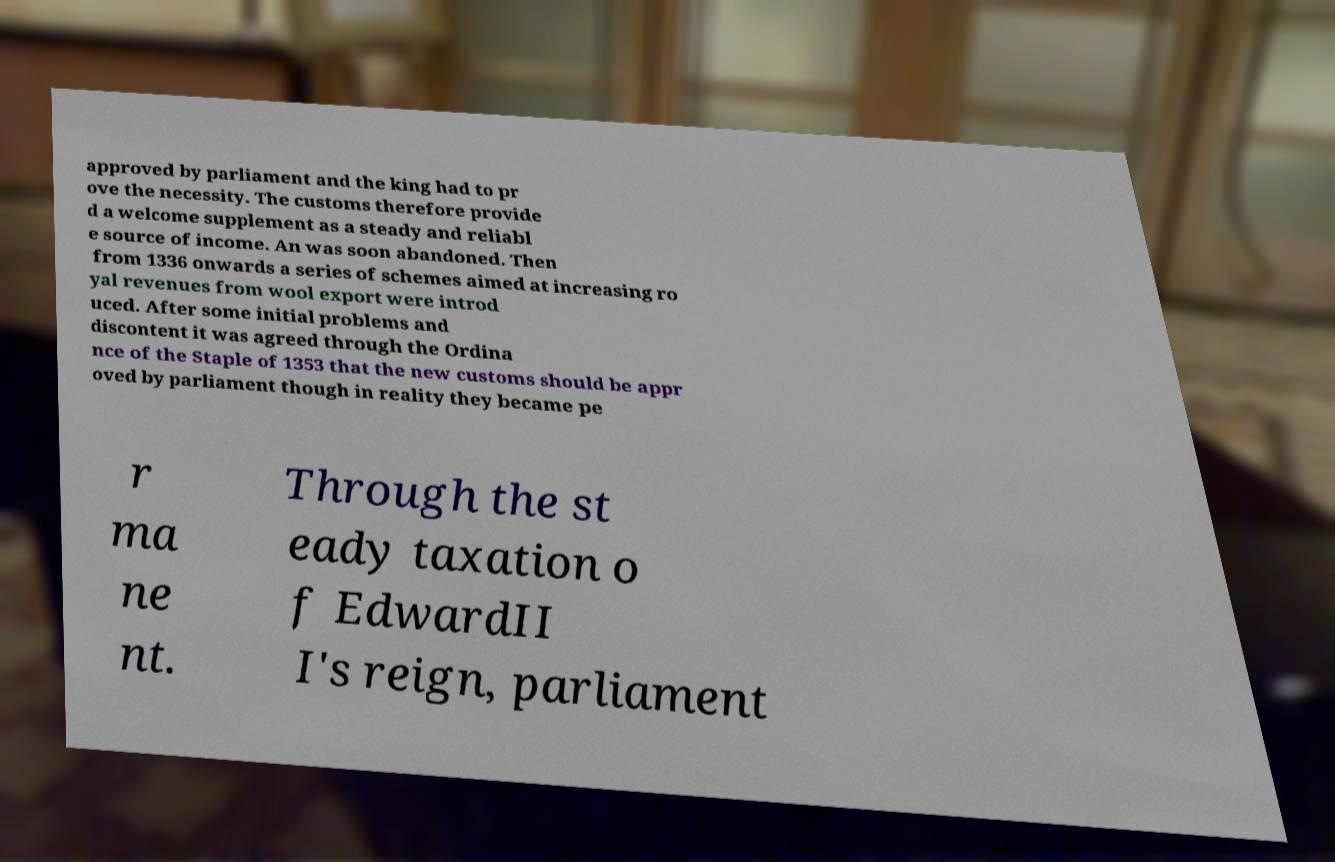Please identify and transcribe the text found in this image. approved by parliament and the king had to pr ove the necessity. The customs therefore provide d a welcome supplement as a steady and reliabl e source of income. An was soon abandoned. Then from 1336 onwards a series of schemes aimed at increasing ro yal revenues from wool export were introd uced. After some initial problems and discontent it was agreed through the Ordina nce of the Staple of 1353 that the new customs should be appr oved by parliament though in reality they became pe r ma ne nt. Through the st eady taxation o f EdwardII I's reign, parliament 